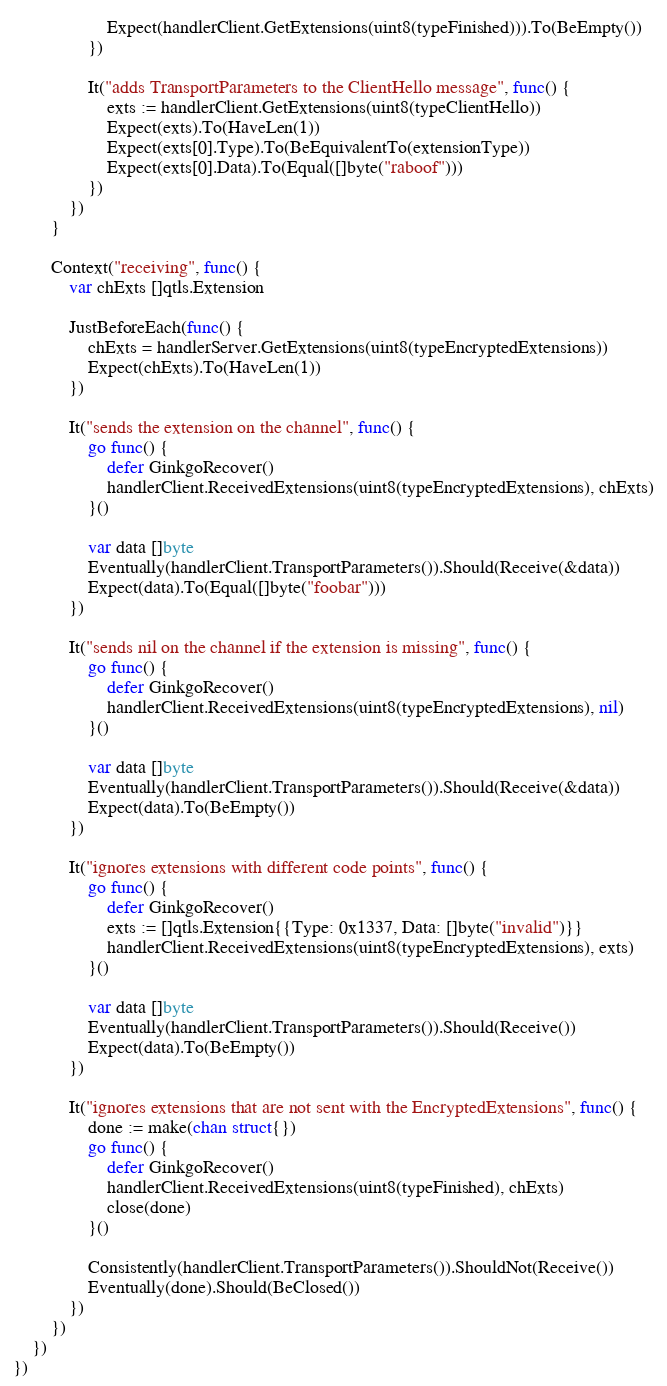Convert code to text. <code><loc_0><loc_0><loc_500><loc_500><_Go_>					Expect(handlerClient.GetExtensions(uint8(typeFinished))).To(BeEmpty())
				})

				It("adds TransportParameters to the ClientHello message", func() {
					exts := handlerClient.GetExtensions(uint8(typeClientHello))
					Expect(exts).To(HaveLen(1))
					Expect(exts[0].Type).To(BeEquivalentTo(extensionType))
					Expect(exts[0].Data).To(Equal([]byte("raboof")))
				})
			})
		}

		Context("receiving", func() {
			var chExts []qtls.Extension

			JustBeforeEach(func() {
				chExts = handlerServer.GetExtensions(uint8(typeEncryptedExtensions))
				Expect(chExts).To(HaveLen(1))
			})

			It("sends the extension on the channel", func() {
				go func() {
					defer GinkgoRecover()
					handlerClient.ReceivedExtensions(uint8(typeEncryptedExtensions), chExts)
				}()

				var data []byte
				Eventually(handlerClient.TransportParameters()).Should(Receive(&data))
				Expect(data).To(Equal([]byte("foobar")))
			})

			It("sends nil on the channel if the extension is missing", func() {
				go func() {
					defer GinkgoRecover()
					handlerClient.ReceivedExtensions(uint8(typeEncryptedExtensions), nil)
				}()

				var data []byte
				Eventually(handlerClient.TransportParameters()).Should(Receive(&data))
				Expect(data).To(BeEmpty())
			})

			It("ignores extensions with different code points", func() {
				go func() {
					defer GinkgoRecover()
					exts := []qtls.Extension{{Type: 0x1337, Data: []byte("invalid")}}
					handlerClient.ReceivedExtensions(uint8(typeEncryptedExtensions), exts)
				}()

				var data []byte
				Eventually(handlerClient.TransportParameters()).Should(Receive())
				Expect(data).To(BeEmpty())
			})

			It("ignores extensions that are not sent with the EncryptedExtensions", func() {
				done := make(chan struct{})
				go func() {
					defer GinkgoRecover()
					handlerClient.ReceivedExtensions(uint8(typeFinished), chExts)
					close(done)
				}()

				Consistently(handlerClient.TransportParameters()).ShouldNot(Receive())
				Eventually(done).Should(BeClosed())
			})
		})
	})
})
</code> 